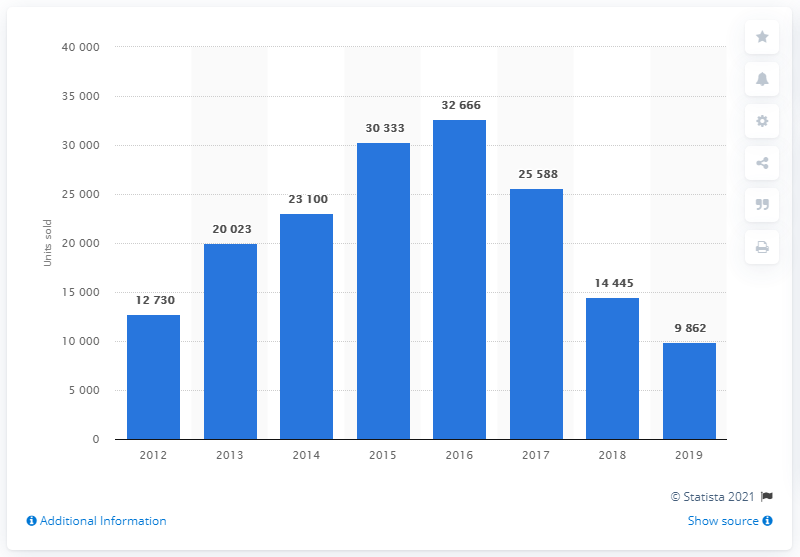Give some essential details in this illustration. During the period of 2012 to 2016, a total of 12,730 Mercedes cars were sold in Turkey. In 2019, a total of 9,862 Mercedes cars were sold in Turkey. 